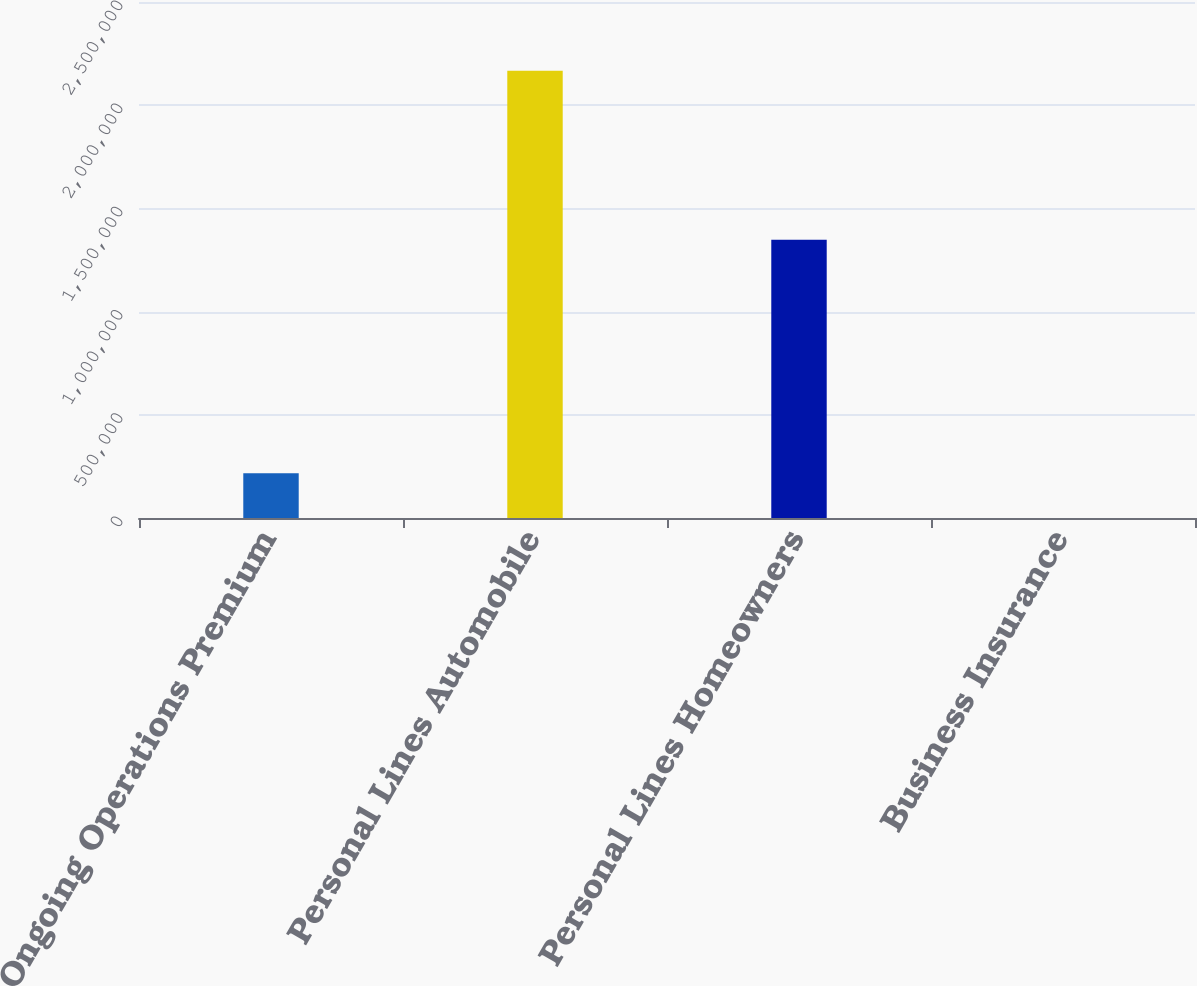Convert chart. <chart><loc_0><loc_0><loc_500><loc_500><bar_chart><fcel>Ongoing Operations Premium<fcel>Personal Lines Automobile<fcel>Personal Lines Homeowners<fcel>Business Insurance<nl><fcel>216694<fcel>2.16692e+06<fcel>1.34857e+06<fcel>2<nl></chart> 